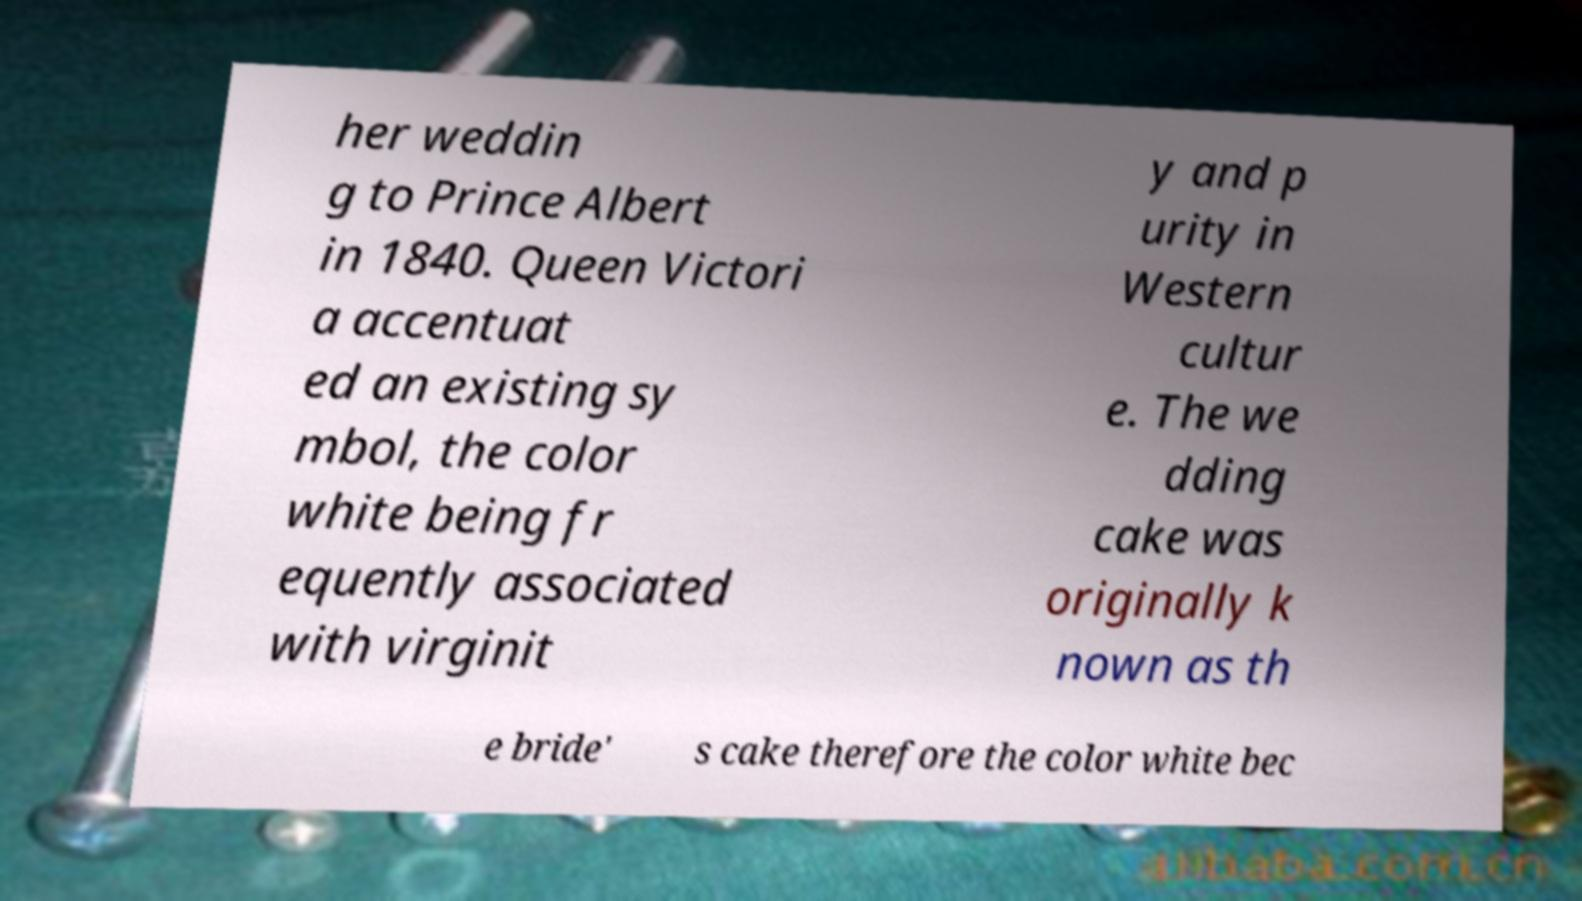Can you accurately transcribe the text from the provided image for me? her weddin g to Prince Albert in 1840. Queen Victori a accentuat ed an existing sy mbol, the color white being fr equently associated with virginit y and p urity in Western cultur e. The we dding cake was originally k nown as th e bride' s cake therefore the color white bec 